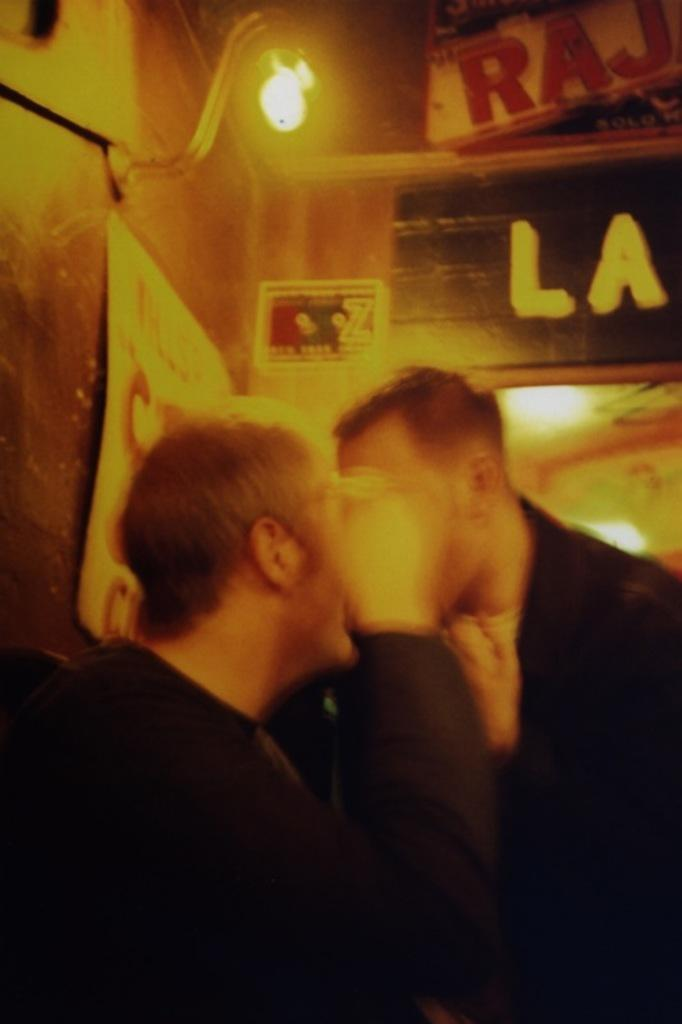What is the overall quality of the image? The image is blurred. How many people are present in the image? There are two persons in the image. Can you describe the lighting in the image? There is a light source in the image. What can be seen written in the image? There is something written in the image. What type of background is visible in the image? There is a wall in the image. What type of necklace is the person wearing in the image? There is no necklace visible in the image, as it is blurred and the details of the persons' clothing or accessories are not discernible. 